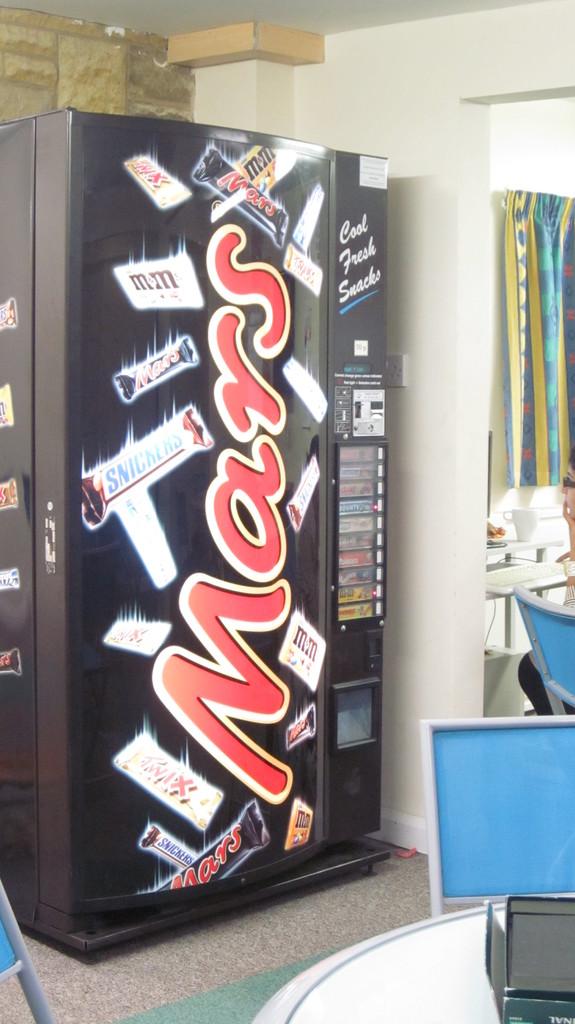Does that machine actually dispense mars bars?
Make the answer very short. Yes. What is picture?
Provide a short and direct response. Mars. 